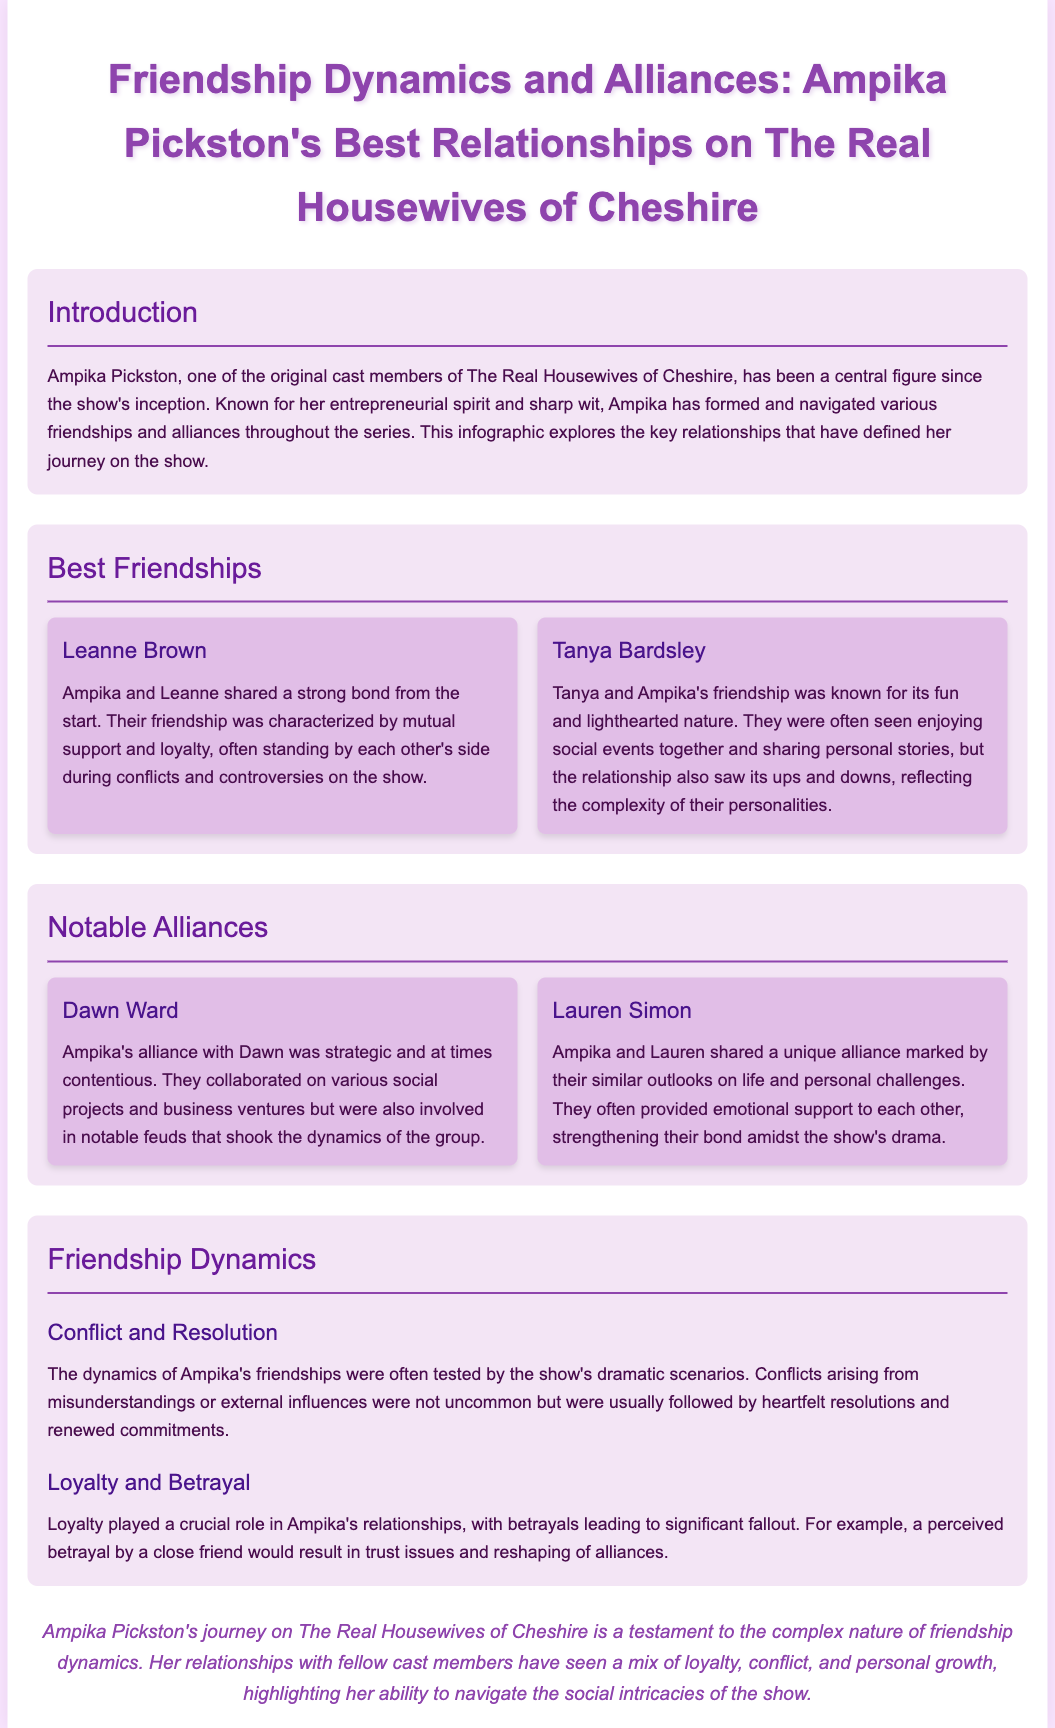what is the title of the infographic? The title of the infographic is stated at the top of the document, emphasizing Ampika Pickston's relationships.
Answer: Friendship Dynamics and Alliances: Ampika Pickston's Best Relationships on The Real Housewives of Cheshire who is Ampika Pickston's best friend mentioned in the document? The document explicitly mentions Leanne Brown as Ampika's best friend.
Answer: Leanne Brown which character had a friendship characterized by fun and lighthearted nature? The friendship described as fun and lighthearted is clearly stated in the section about Tanya Bardsley.
Answer: Tanya Bardsley how many notable alliances are mentioned in the document? The document specifies two notable alliances that Ampika had during the show.
Answer: Two what type of conflict is commonly seen in Ampika's relationships? The document discusses conflicts arising from misunderstandings or external influences in Ampika's friendships.
Answer: Misunderstandings who provided emotional support to each other in their unique alliance? The document highlights that Ampika and Lauren Simon often provided emotional support to each other.
Answer: Lauren Simon what played a crucial role in Ampika's relationships according to the document? The document states that loyalty played a crucial role in Ampika's relationships.
Answer: Loyalty which section discusses the ups and downs of friendships? The section detailing the complexities of friendships, including ups and downs, is mentioned under Notable Alliances.
Answer: Notable Alliances 